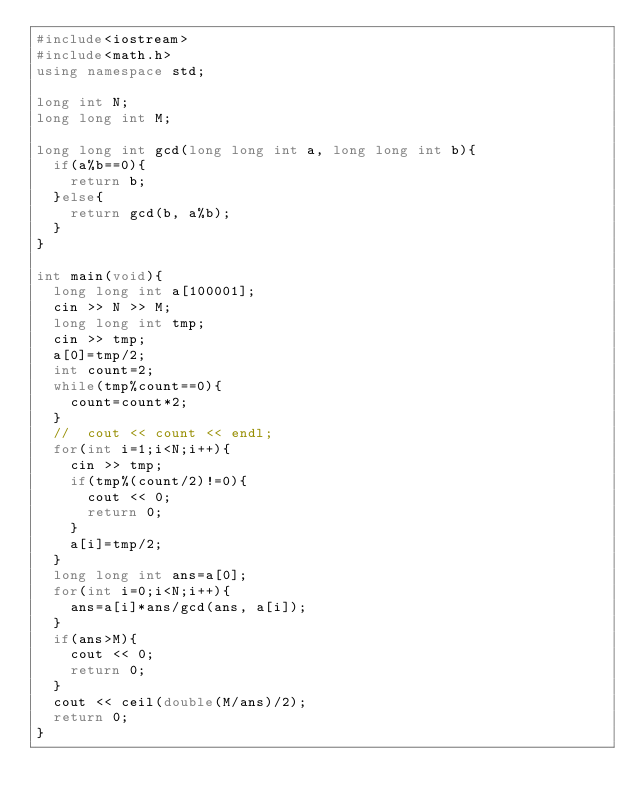Convert code to text. <code><loc_0><loc_0><loc_500><loc_500><_C++_>#include<iostream>
#include<math.h>
using namespace std;

long int N;
long long int M;

long long int gcd(long long int a, long long int b){
  if(a%b==0){
    return b;
  }else{
    return gcd(b, a%b);
  }
}

int main(void){
  long long int a[100001];
  cin >> N >> M;
  long long int tmp; 
  cin >> tmp;
  a[0]=tmp/2;
  int count=2;
  while(tmp%count==0){
    count=count*2;
  }
  //  cout << count << endl;
  for(int i=1;i<N;i++){
    cin >> tmp;    
    if(tmp%(count/2)!=0){
      cout << 0;
      return 0;
    }
    a[i]=tmp/2; 
  }
  long long int ans=a[0];
  for(int i=0;i<N;i++){
    ans=a[i]*ans/gcd(ans, a[i]);
  }
  if(ans>M){
    cout << 0;
    return 0;
  }
  cout << ceil(double(M/ans)/2);
  return 0;
}
</code> 